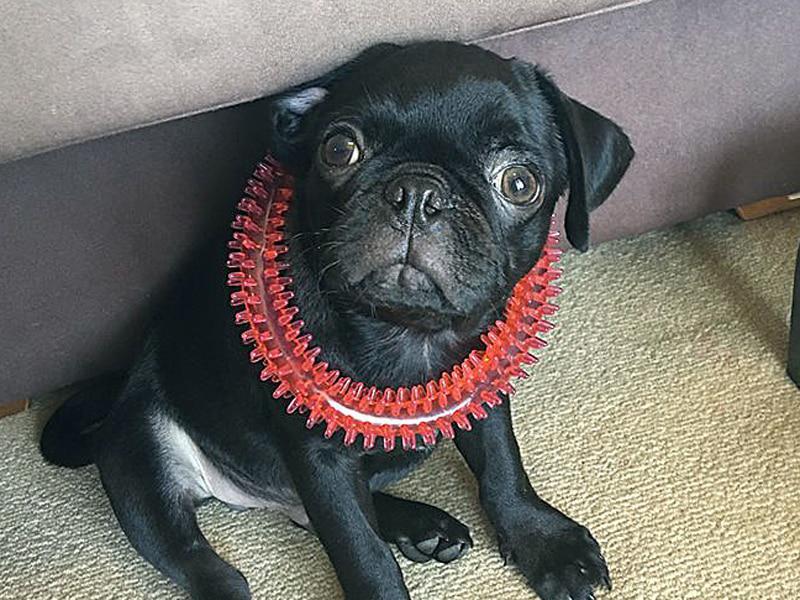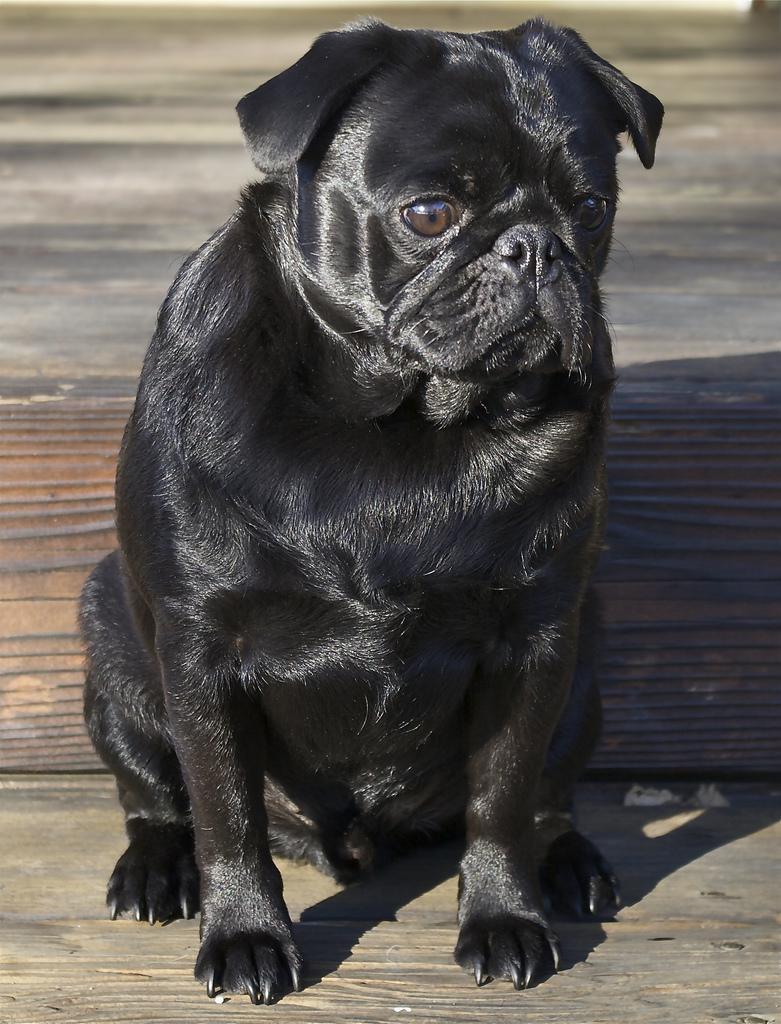The first image is the image on the left, the second image is the image on the right. Analyze the images presented: Is the assertion "There are at least four pugs." valid? Answer yes or no. No. The first image is the image on the left, the second image is the image on the right. For the images displayed, is the sentence "All dogs are in soft-sided containers, and all dogs are light tan with dark faces." factually correct? Answer yes or no. No. 